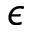<formula> <loc_0><loc_0><loc_500><loc_500>\epsilon</formula> 